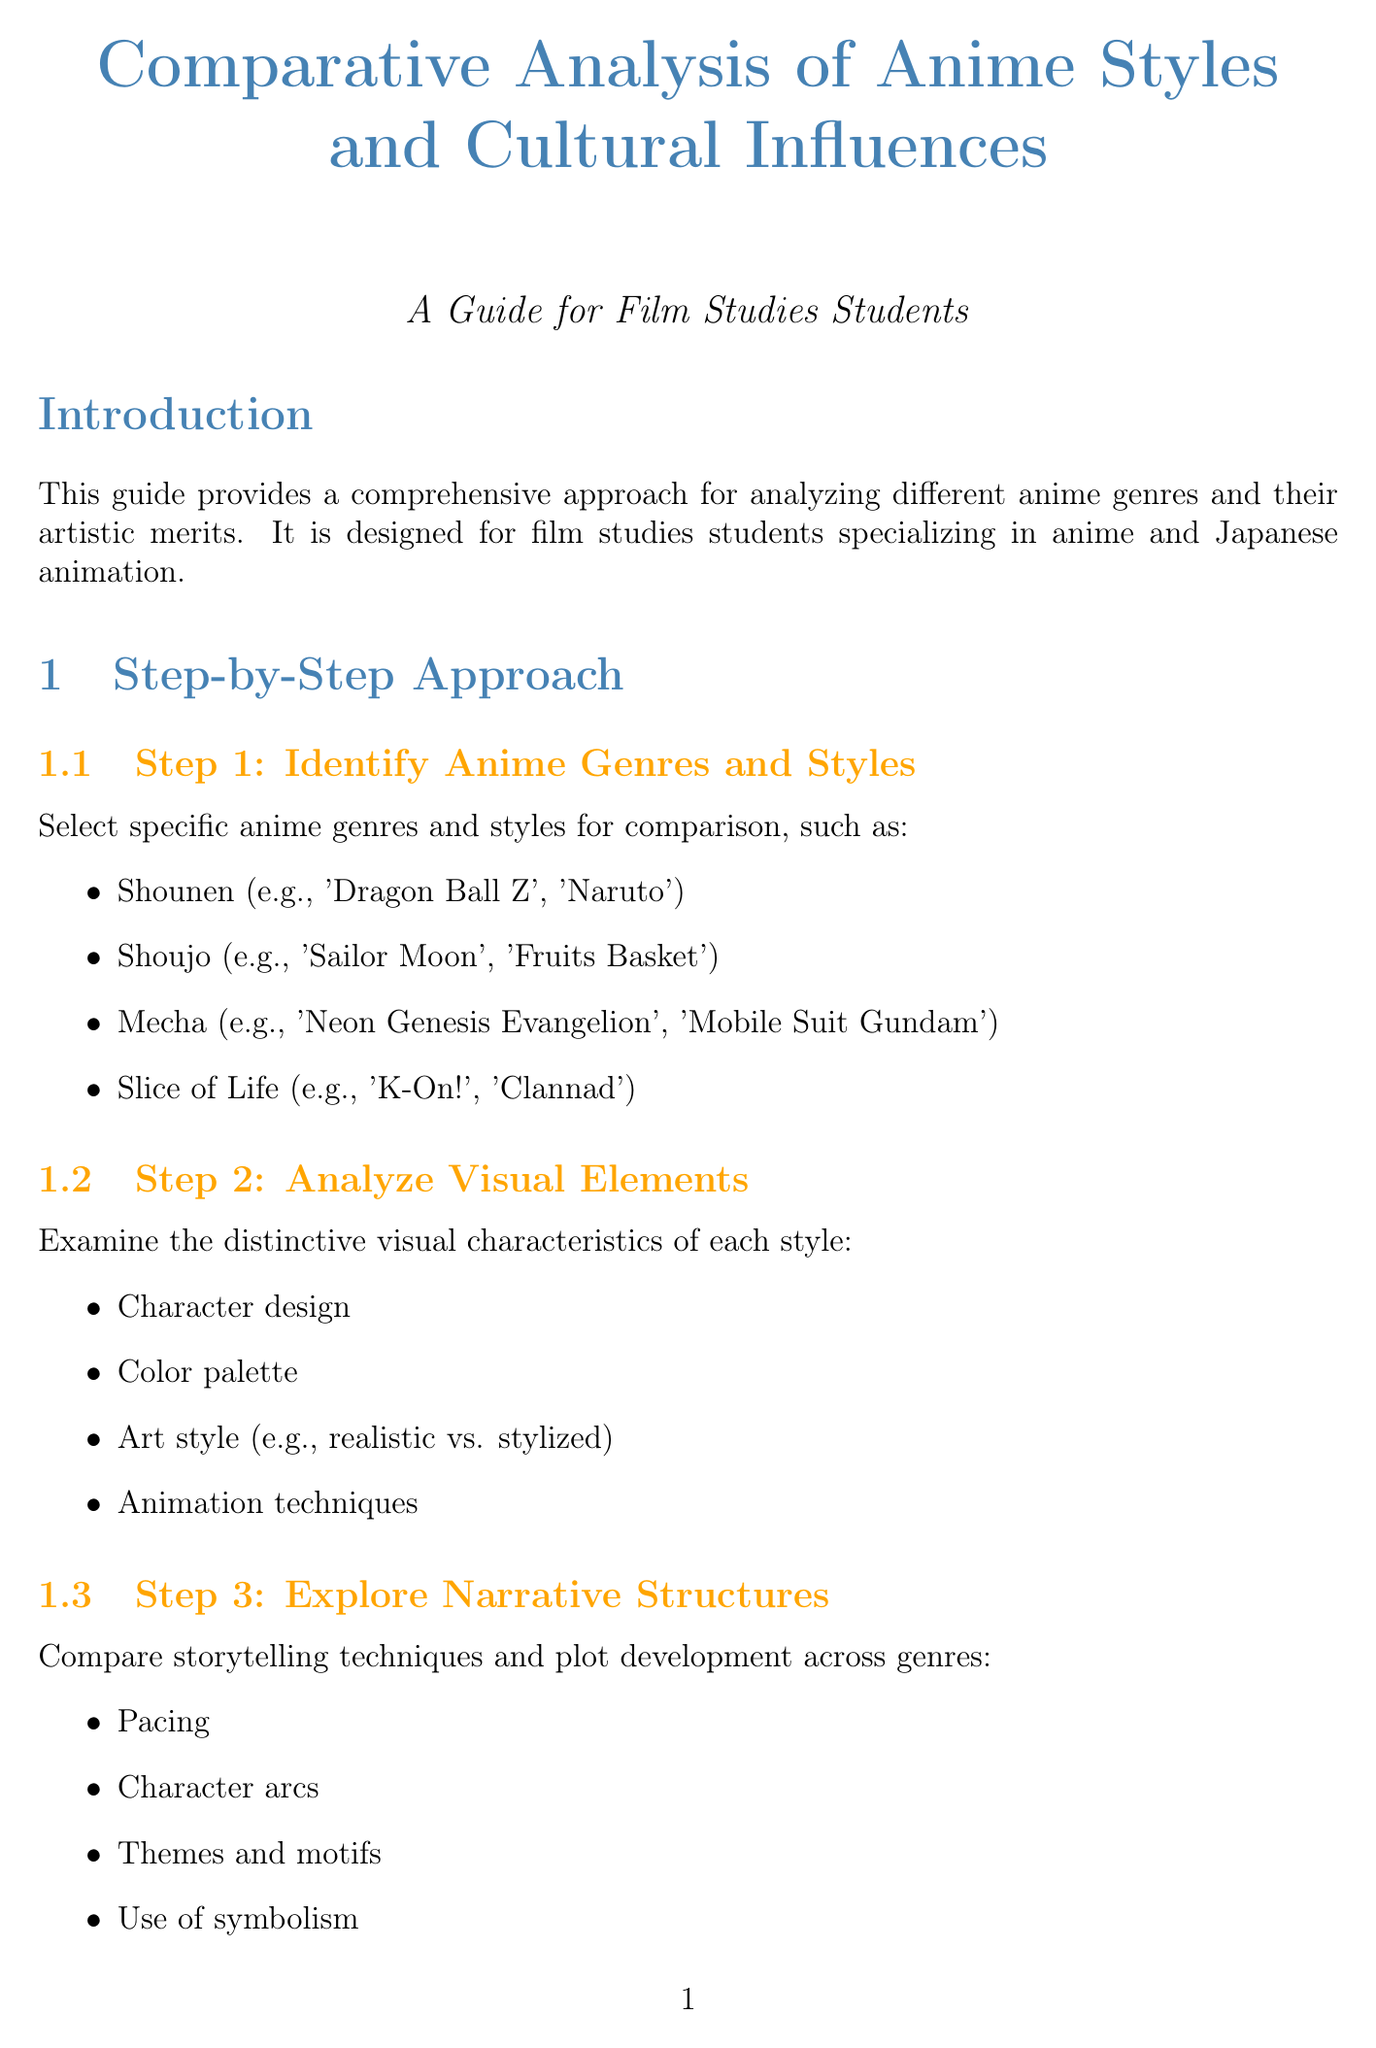what is the title of the manual? The title of the manual is the main heading at the top of the document, presenting its subject matter.
Answer: Comparative Analysis of Anime Styles and Cultural Influences: A Guide for Film Studies Students who is the target audience of the manual? The target audience is specified in the introduction, where the purpose of the manual is outlined.
Answer: Film studies students specializing in anime and Japanese animation how many steps are in the step-by-step approach? The number of steps is listed as part of the structured approach, indicating the methodical process outlined in the document.
Answer: 10 what genre is analyzed in the case study titled "The Evolution of Mecha Anime"? The case study title indicates that the focus is on a specific genre of anime, which is highlighted in the subtitle.
Answer: Mecha which book is recommended for understanding the history of anime? The manual includes a list of resources, specifically mentioning a book that covers anime history as a reference for further reading.
Answer: Anime: A History by Jonathan Clements what aspect of anime is explored in Step 4? Step 4 focuses on a key thematic area in the manual, detailing an important context for understanding anime styles.
Answer: Cultural Influences list one area of focus in Step 4. The areas of focus are explicitly outlined in Step 4, presenting several specific aspects to explore regarding cultural influences in anime.
Answer: Japanese social norms and values 